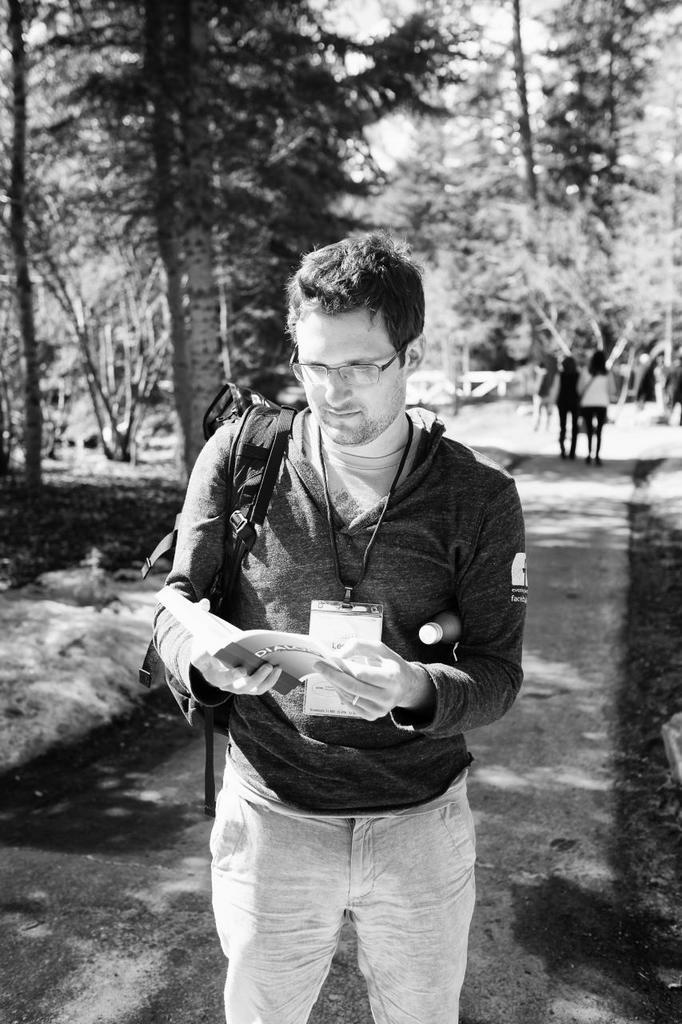What is the person in the image holding? The person is holding a book in the image. What is the person wearing on their back? The person is wearing a backpack. Where is the person standing? The person is standing on the ground. What can be seen in the background of the image? There are trees visible at the top of the image. How many people are in the middle of the image? There are two persons in the middle of the image. What news is the grandmother sharing with the person holding the book? There is no grandmother present in the image, and therefore no news can be shared. 